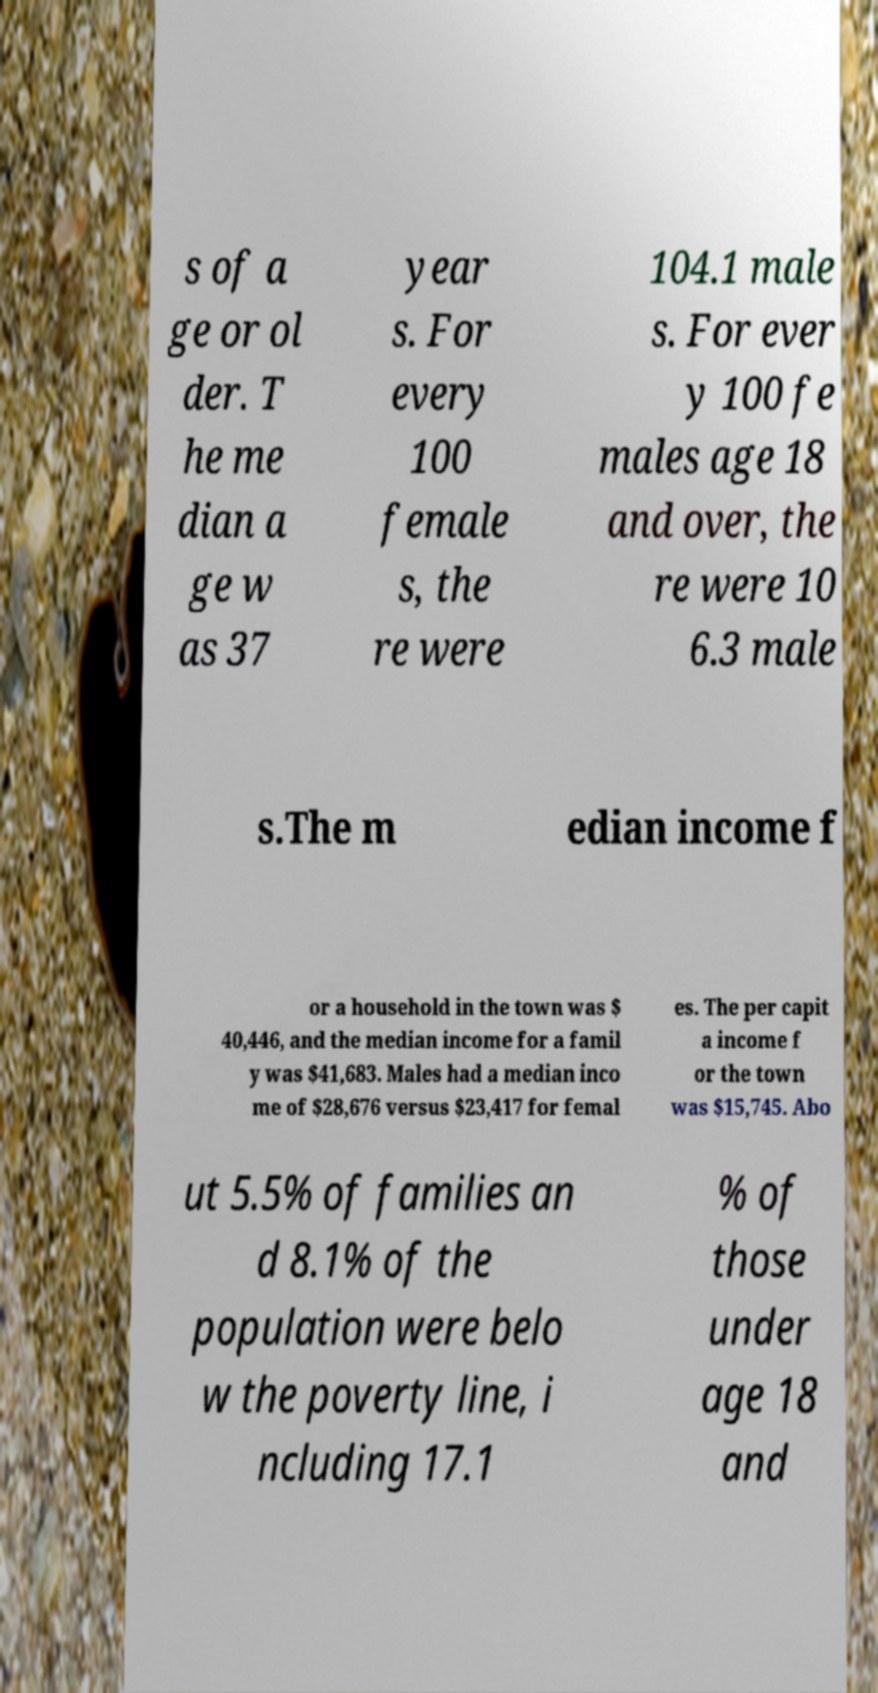What messages or text are displayed in this image? I need them in a readable, typed format. s of a ge or ol der. T he me dian a ge w as 37 year s. For every 100 female s, the re were 104.1 male s. For ever y 100 fe males age 18 and over, the re were 10 6.3 male s.The m edian income f or a household in the town was $ 40,446, and the median income for a famil y was $41,683. Males had a median inco me of $28,676 versus $23,417 for femal es. The per capit a income f or the town was $15,745. Abo ut 5.5% of families an d 8.1% of the population were belo w the poverty line, i ncluding 17.1 % of those under age 18 and 